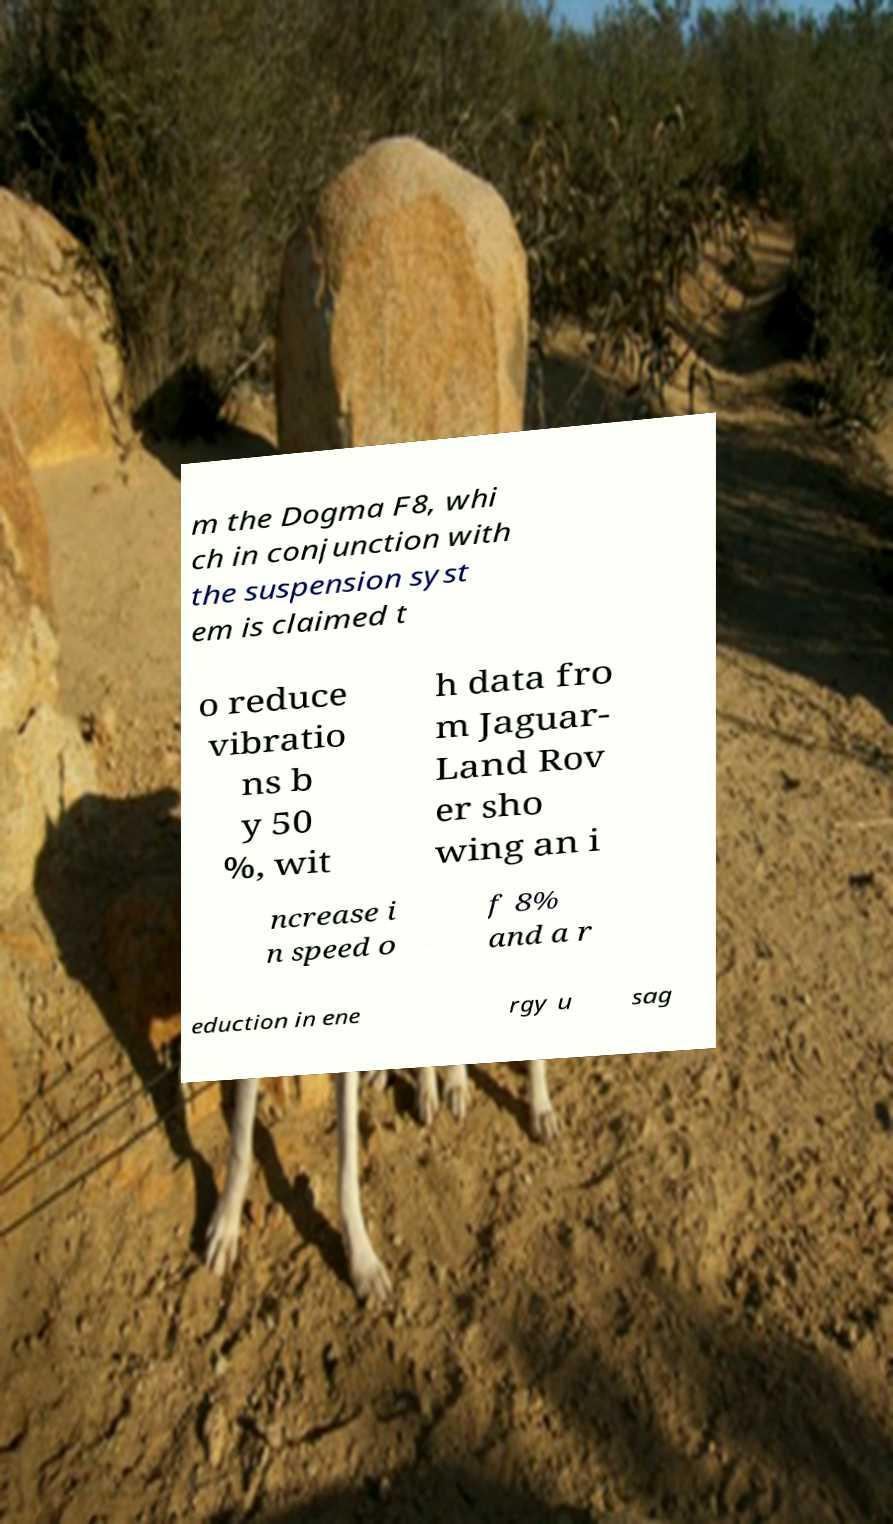Can you read and provide the text displayed in the image?This photo seems to have some interesting text. Can you extract and type it out for me? m the Dogma F8, whi ch in conjunction with the suspension syst em is claimed t o reduce vibratio ns b y 50 %, wit h data fro m Jaguar- Land Rov er sho wing an i ncrease i n speed o f 8% and a r eduction in ene rgy u sag 